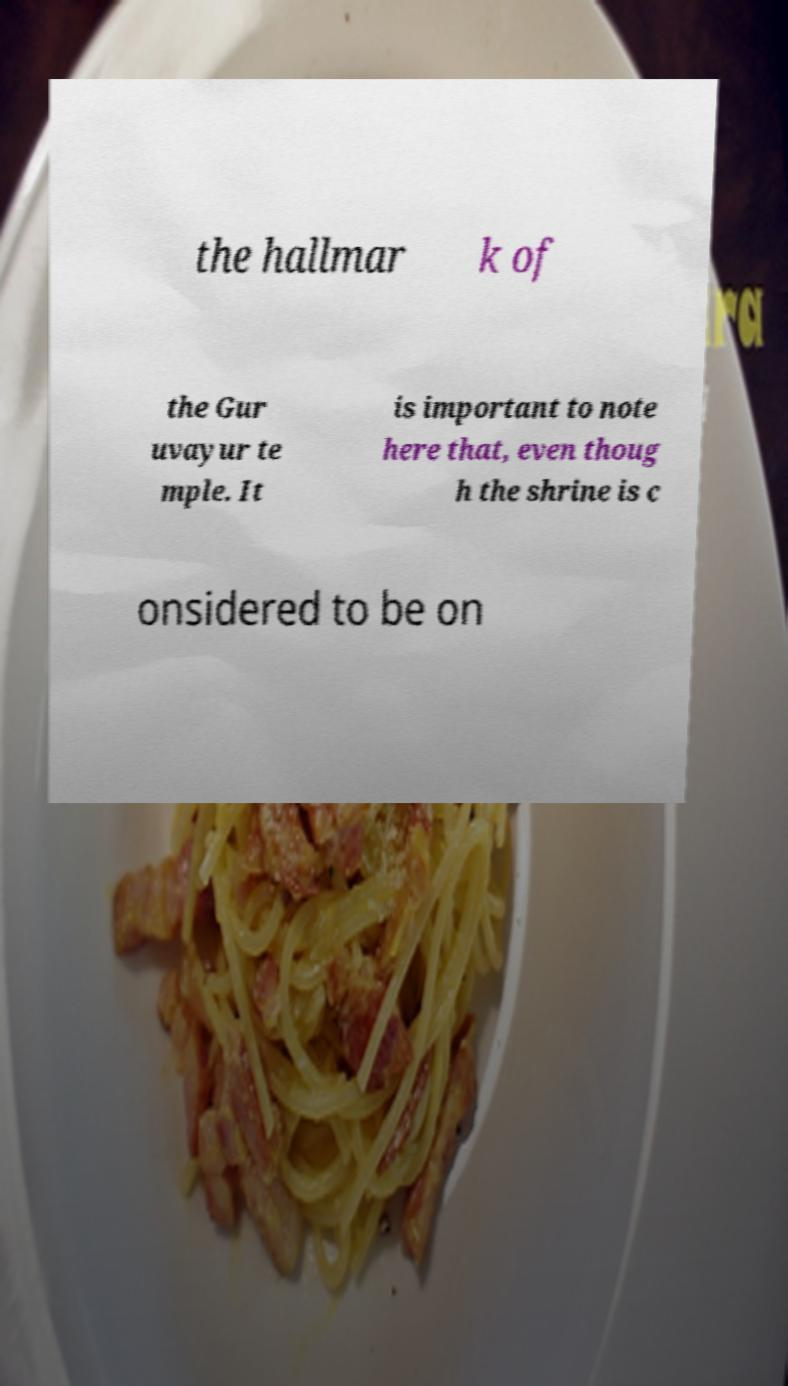There's text embedded in this image that I need extracted. Can you transcribe it verbatim? the hallmar k of the Gur uvayur te mple. It is important to note here that, even thoug h the shrine is c onsidered to be on 